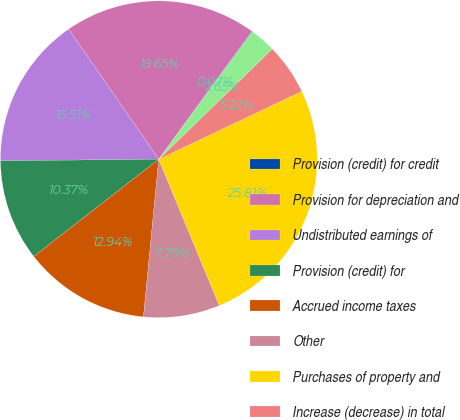Convert chart. <chart><loc_0><loc_0><loc_500><loc_500><pie_chart><fcel>Provision (credit) for credit<fcel>Provision for depreciation and<fcel>Undistributed earnings of<fcel>Provision (credit) for<fcel>Accrued income taxes<fcel>Other<fcel>Purchases of property and<fcel>Increase (decrease) in total<fcel>Effect of Exchange Rate<nl><fcel>0.07%<fcel>19.65%<fcel>15.51%<fcel>10.37%<fcel>12.94%<fcel>7.79%<fcel>25.81%<fcel>5.22%<fcel>2.65%<nl></chart> 